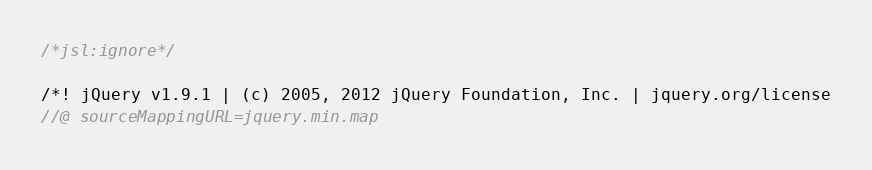<code> <loc_0><loc_0><loc_500><loc_500><_JavaScript_>
/*jsl:ignore*/

/*! jQuery v1.9.1 | (c) 2005, 2012 jQuery Foundation, Inc. | jquery.org/license
//@ sourceMappingURL=jquery.min.map</code> 